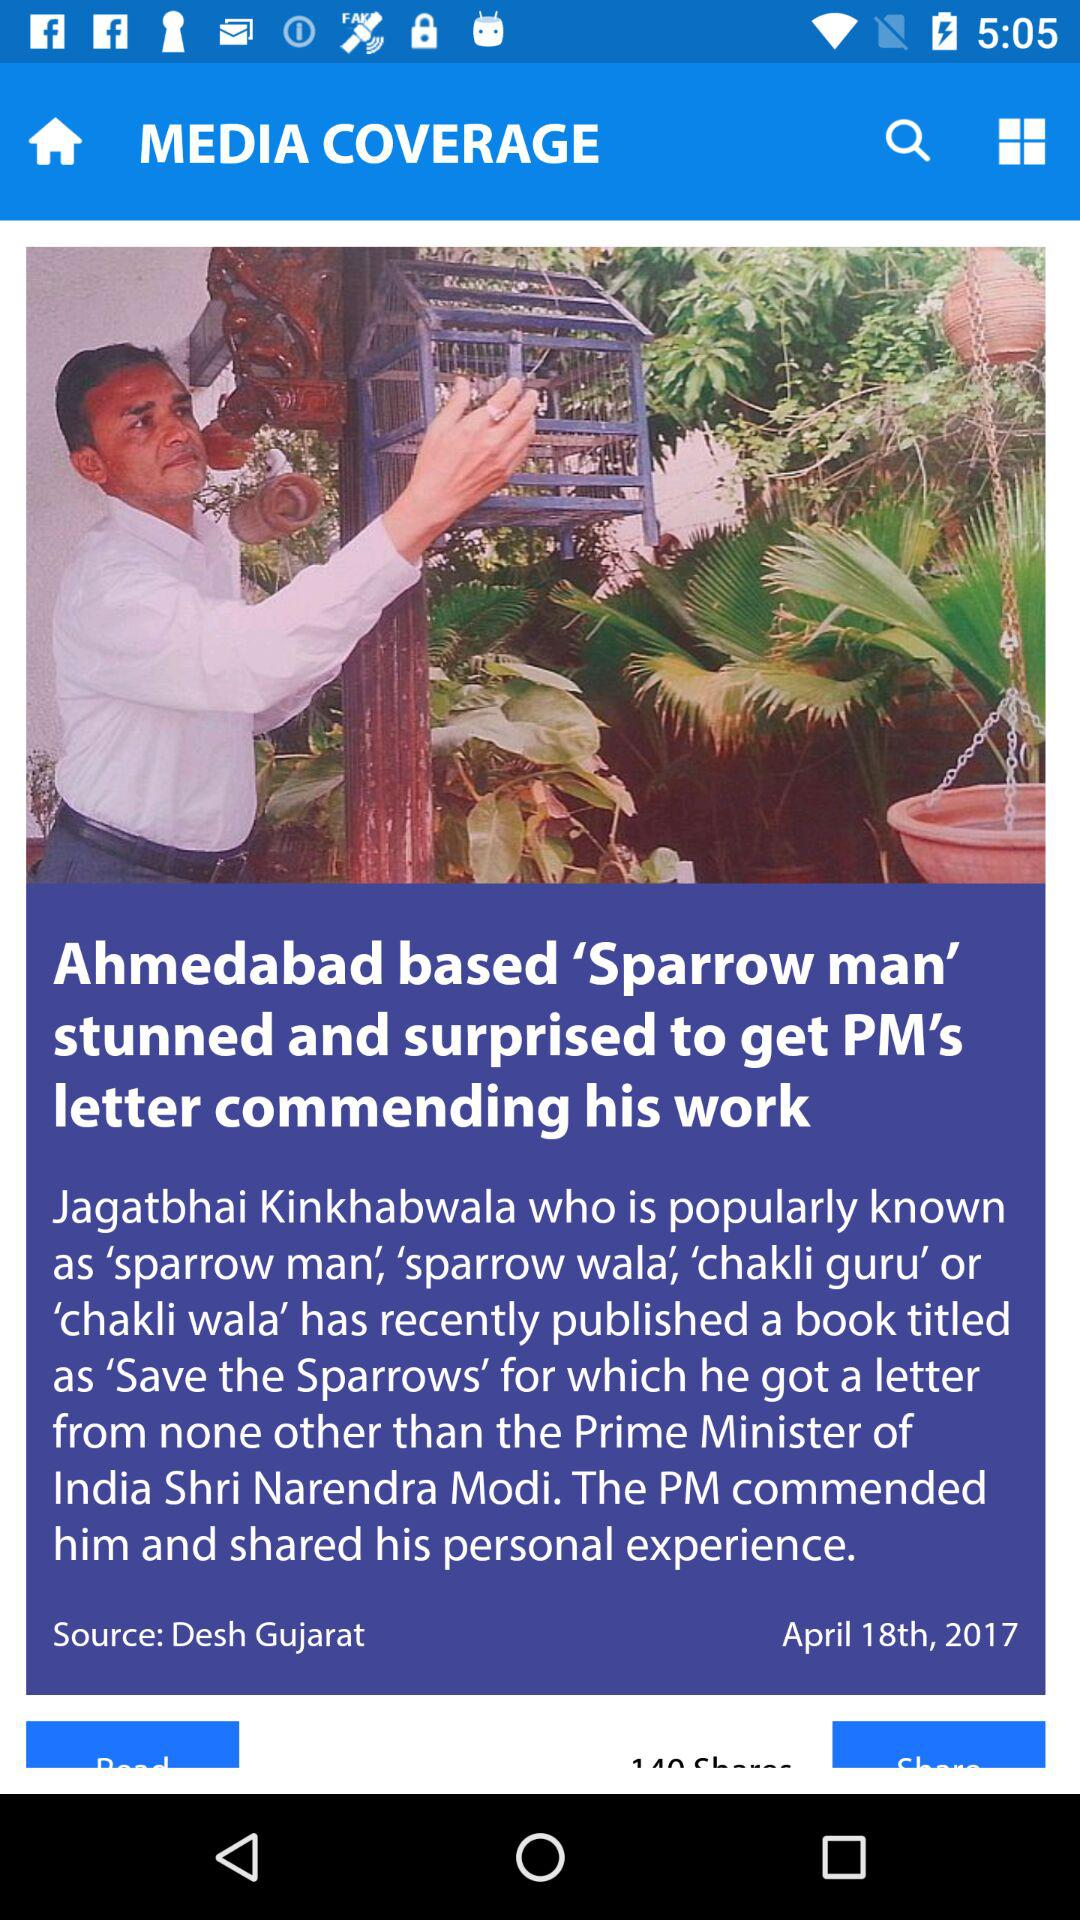What is the source of this news? The source is "Desh Gujarat". 